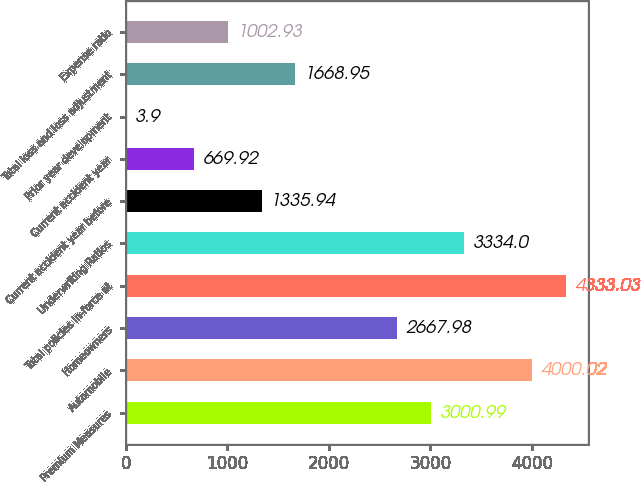Convert chart to OTSL. <chart><loc_0><loc_0><loc_500><loc_500><bar_chart><fcel>Premium Measures<fcel>Automobile<fcel>Homeowners<fcel>Total policies in-force at<fcel>Underwriting Ratios<fcel>Current accident year before<fcel>Current accident year<fcel>Prior year development<fcel>Total loss and loss adjustment<fcel>Expense ratio<nl><fcel>3000.99<fcel>4000.02<fcel>2667.98<fcel>4333.03<fcel>3334<fcel>1335.94<fcel>669.92<fcel>3.9<fcel>1668.95<fcel>1002.93<nl></chart> 